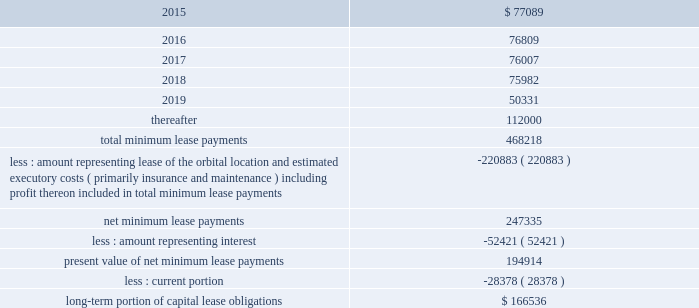Dish network corporation notes to consolidated financial statements - continued capital lease obligations anik f3 .
Anik f3 , an fss satellite , was launched and commenced commercial operation during april 2007 .
This satellite is accounted for as a capital lease and depreciated over the term of the satellite service agreement .
We have leased 100% ( 100 % ) of the ku-band capacity on anik f3 for a period of 15 years .
Ciel ii .
Ciel ii , a canadian dbs satellite , was launched in december 2008 and commenced commercial operation during february 2009 .
This satellite is accounted for as a capital lease and depreciated over the term of the satellite service agreement .
We have leased 100% ( 100 % ) of the capacity on ciel ii for an initial 10 year term .
As of december 31 , 2014 and 2013 , we had $ 500 million capitalized for the estimated fair value of satellites acquired under capital leases included in 201cproperty and equipment , net , 201d with related accumulated depreciation of $ 279 million and $ 236 million , respectively .
In our consolidated statements of operations and comprehensive income ( loss ) , we recognized $ 43 million , $ 43 million and $ 43 million in depreciation expense on satellites acquired under capital lease agreements during the years ended december 31 , 2014 , 2013 and 2012 , respectively .
Future minimum lease payments under the capital lease obligations , together with the present value of the net minimum lease payments as of december 31 , 2014 are as follows ( in thousands ) : for the years ended december 31 .
The summary of future maturities of our outstanding long-term debt as of december 31 , 2014 is included in the commitments table in note 16 .
12 .
Income taxes and accounting for uncertainty in income taxes income taxes our income tax policy is to record the estimated future tax effects of temporary differences between the tax bases of assets and liabilities and amounts reported on our consolidated balance sheets , as well as probable operating loss , tax credit and other carryforwards .
Deferred tax assets are offset by valuation allowances when we believe it is more likely than not that net deferred tax assets will not be realized .
We periodically evaluate our need for a valuation allowance .
Determining necessary valuation allowances requires us to make assessments about historical financial information as well as the timing of future events , including the probability of expected future taxable income and available tax planning opportunities .
We file consolidated tax returns in the u.s .
The income taxes of domestic and foreign subsidiaries not included in the u.s .
Tax group are presented in our consolidated financial statements based on a separate return basis for each tax paying entity. .
What percentage of future minimum lease payments under the capital lease obligations is due after 2019? 
Computations: (112000 / 468218)
Answer: 0.2392. 